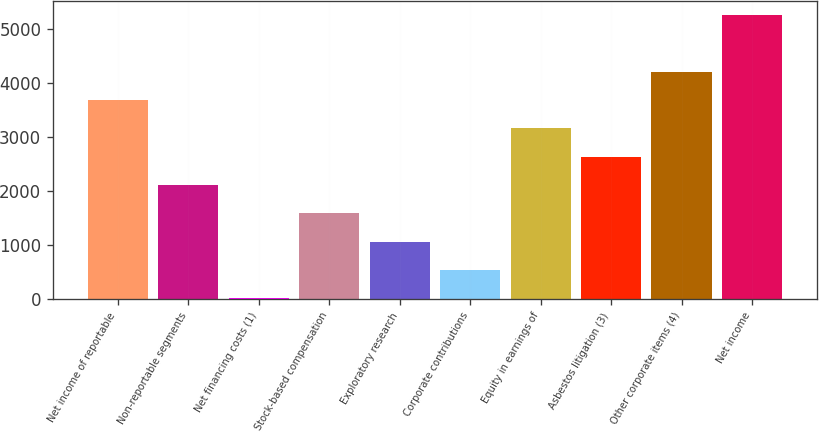<chart> <loc_0><loc_0><loc_500><loc_500><bar_chart><fcel>Net income of reportable<fcel>Non-reportable segments<fcel>Net financing costs (1)<fcel>Stock-based compensation<fcel>Exploratory research<fcel>Corporate contributions<fcel>Equity in earnings of<fcel>Asbestos litigation (3)<fcel>Other corporate items (4)<fcel>Net income<nl><fcel>3684.4<fcel>2111.8<fcel>15<fcel>1587.6<fcel>1063.4<fcel>539.2<fcel>3160.2<fcel>2636<fcel>4208.6<fcel>5257<nl></chart> 